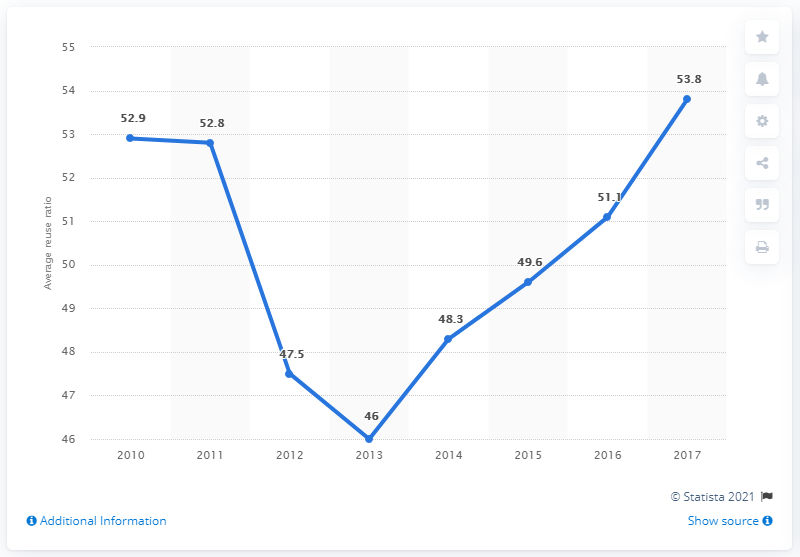List a handful of essential elements in this visual. In 2017, the average reuse ratio of learning hours for L&D was 53.8%. 